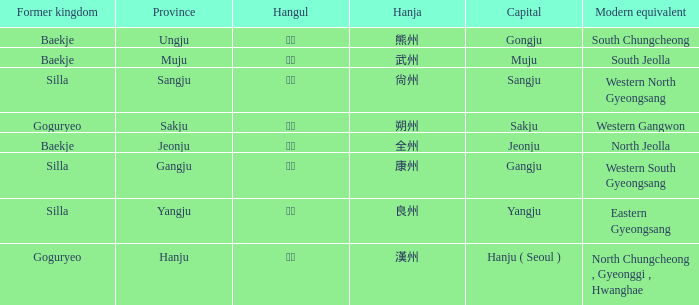What is the hanja representation for the "sangju" province? 尙州. 